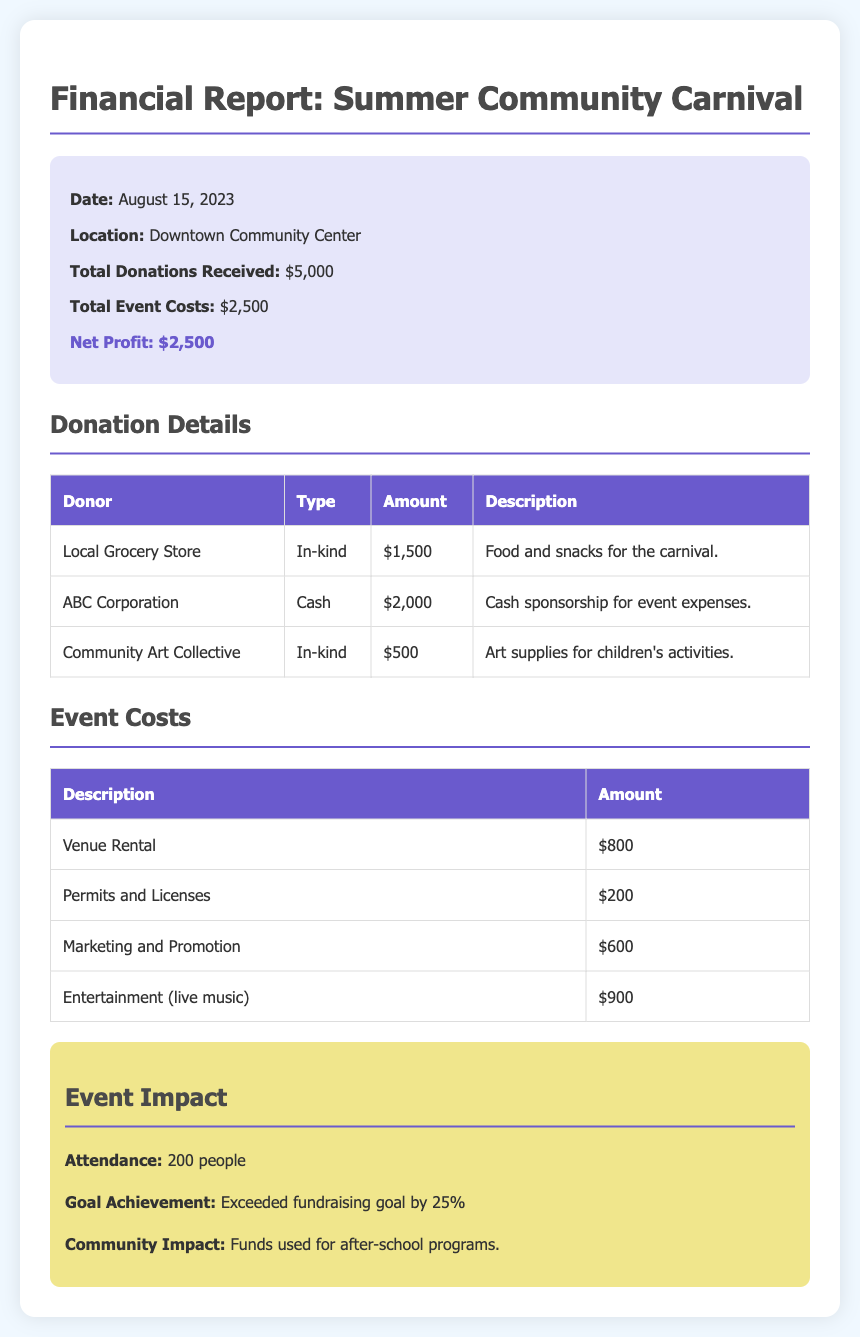What date was the Summer Community Carnival held? The date of the event is clearly stated in the summary section of the document as August 15, 2023.
Answer: August 15, 2023 What was the total amount of donations received? Total donations received is mentioned in the summary section as $5,000.
Answer: $5,000 What type of donation did the Local Grocery Store provide? The type of donation from the Local Grocery Store is listed as in-kind in the donation details table.
Answer: In-kind How much was spent on entertainment for the event? The event costs include $900 spent on entertainment (live music), as detailed in the costs table.
Answer: $900 What was the net profit from the event? The net profit can be calculated from the summary section, which states total donations and total event costs. Net profit is cited as $2,500.
Answer: $2,500 How many people attended the event? The attendance figure is specified in the impact section, indicating 200 people attended.
Answer: 200 What percentage did the fundraising goal exceed? The document states the fundraising goal was exceeded by 25%, as indicated in the impact section.
Answer: 25% What was the total cost for marketing and promotion? The document lists the cost for marketing and promotion as $600 in the event costs table.
Answer: $600 Who was the cash sponsor for the event? ABC Corporation is mentioned as the cash sponsor for event expenses in the donation details table.
Answer: ABC Corporation What funds will the raised amount be used for? According to the impact section, the funds will be used for after-school programs as stated.
Answer: After-school programs 